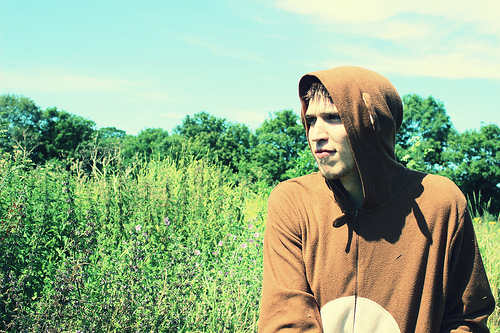<image>
Is the man behind the plants? No. The man is not behind the plants. From this viewpoint, the man appears to be positioned elsewhere in the scene. 